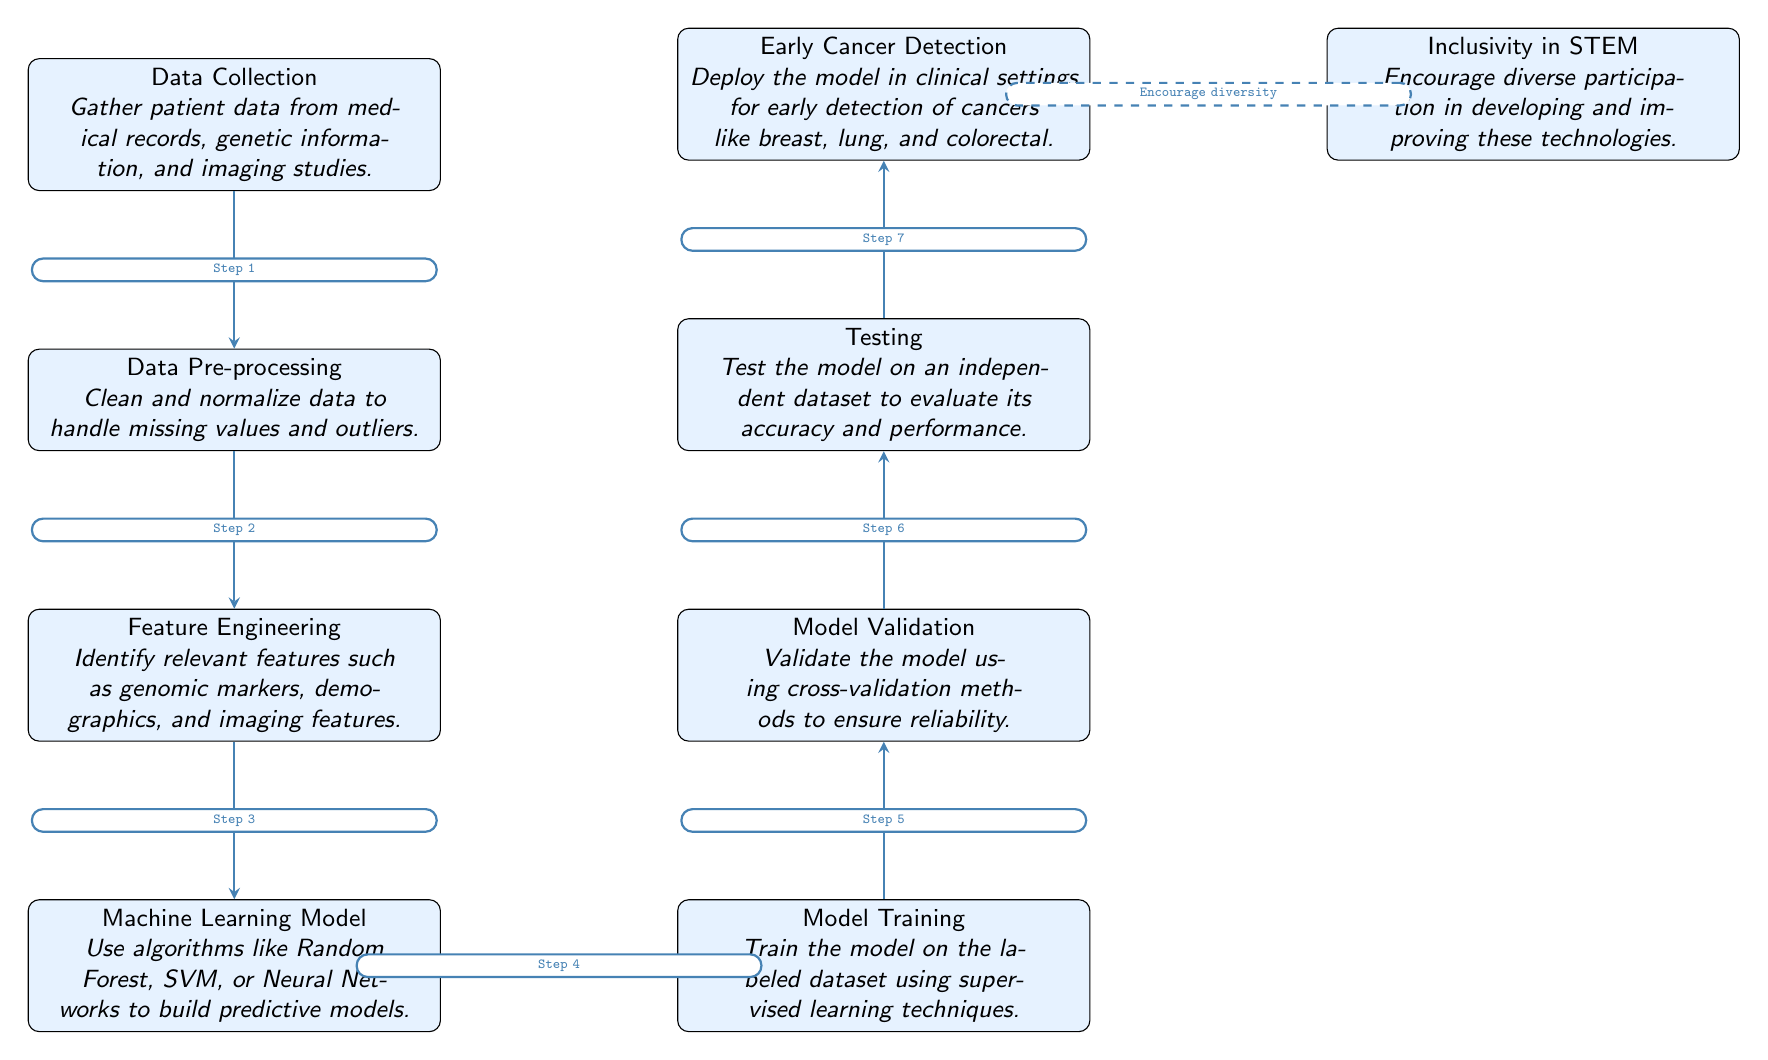What is the first step in the detection process? The first node in the diagram is 'Data Collection,' which indicates that gathering patient data is the initial step in the early cancer detection process.
Answer: Data Collection How many main steps are indicated in the diagram? By counting the nodes in the main detection process from 'Data Collection' to 'Early Cancer Detection,' there are six primary steps listed before inclusivity.
Answer: Six What type of model is used in the machine learning step? The machine learning model node mentions the use of algorithms such as Random Forest, SVM, or Neural Networks, specifying the type of approaches utilized for prediction.
Answer: Algorithms Which step involves cleaning and normalizing data? The diagram specifies 'Data Pre-processing' as the step where data is cleaned and normalized to deal with missing values and outliers, thus directly indicating this activity.
Answer: Data Pre-processing What follows after the 'Model Validation' step? According to the flow indicated in the diagram, 'Testing' immediately follows 'Model Validation,' thus representing the next step in the detection process.
Answer: Testing In which node is diversity in STEM mentioned? The node labeled 'Inclusivity in STEM' at the far right addresses the importance of encouraging diverse participation in technology development, hence where this concept is highlighted.
Answer: Inclusivity in STEM What is the purpose of the 'Feature Engineering' step? This step is explained as identifying relevant features, such as genomic markers and demographics, which are essential for effective cancer prediction, thus serving a clear purpose in the process.
Answer: Identify relevant features How does the model's performance get evaluated? The diagram indicates that the model's performance is evaluated during the 'Testing' step, which is crucial for assessing the accuracy and effectiveness of the developed predictive models.
Answer: Testing Which step comes right before deploying the model in clinical settings? 'Testing' is the step just prior to 'Early Cancer Detection,' indicating that successful testing must occur before the model is implemented in a clinical context for actual cancer detection.
Answer: Testing 